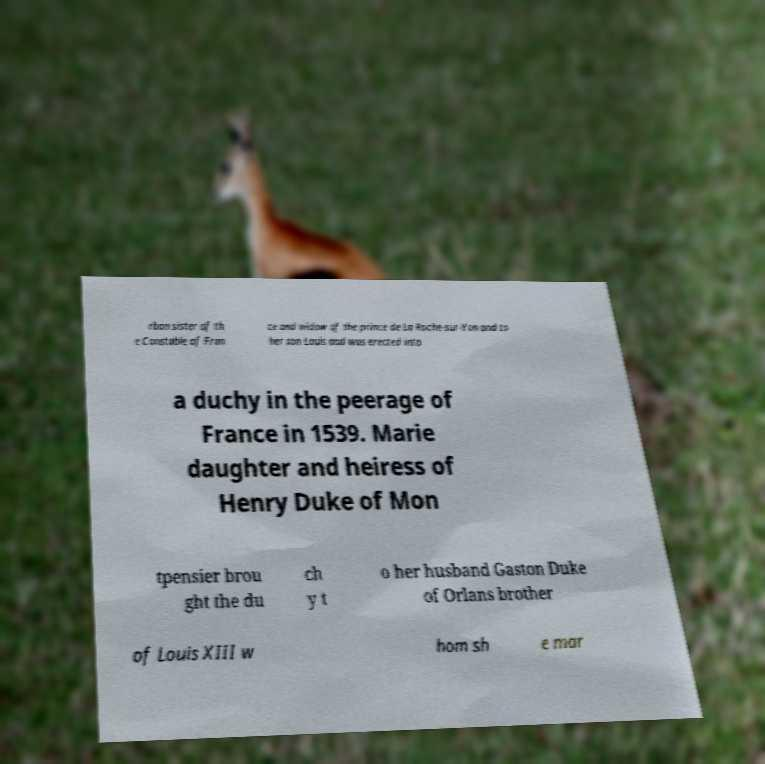Could you assist in decoding the text presented in this image and type it out clearly? rbon sister of th e Constable of Fran ce and widow of the prince de La Roche-sur-Yon and to her son Louis and was erected into a duchy in the peerage of France in 1539. Marie daughter and heiress of Henry Duke of Mon tpensier brou ght the du ch y t o her husband Gaston Duke of Orlans brother of Louis XIII w hom sh e mar 